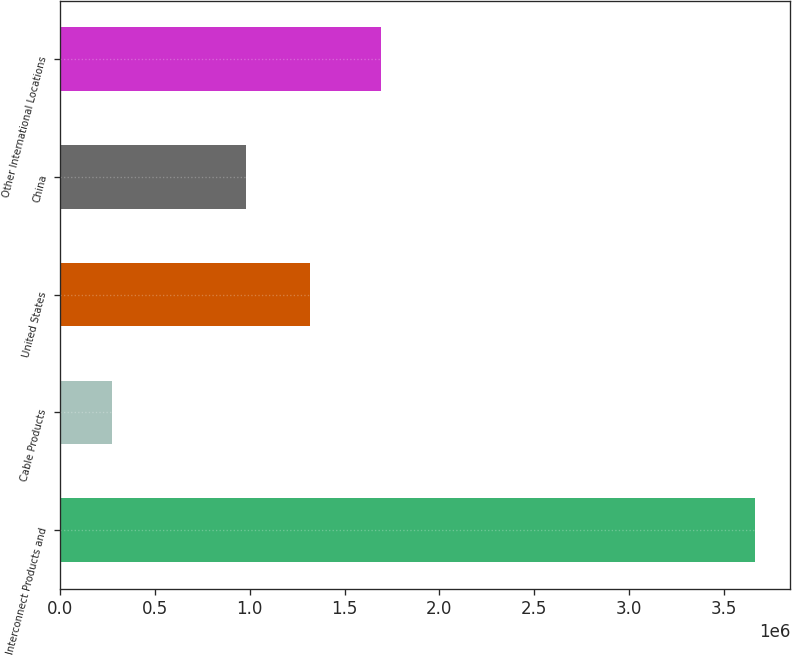<chart> <loc_0><loc_0><loc_500><loc_500><bar_chart><fcel>Interconnect Products and<fcel>Cable Products<fcel>United States<fcel>China<fcel>Other International Locations<nl><fcel>3.66604e+06<fcel>273744<fcel>1.31947e+06<fcel>980239<fcel>1.69061e+06<nl></chart> 